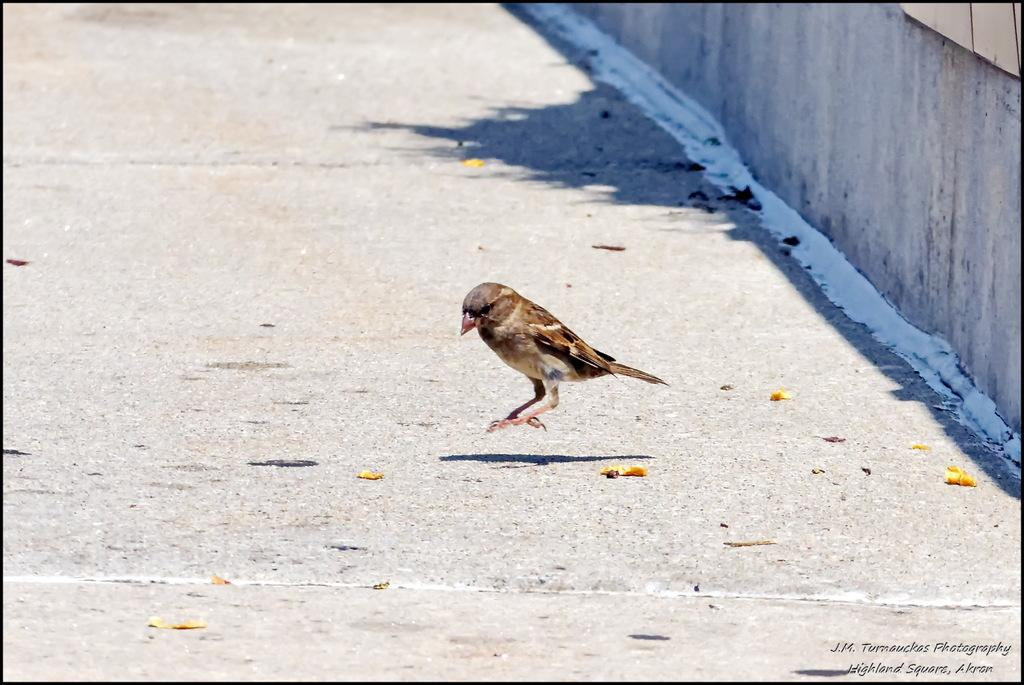What animal can be seen on the road in the image? There is a bird on the road in the image. What type of structure is present in the image? There is a wall in the image. What is placed on the wall? There is an object on the wall. What can be read or seen in the image? There is text visible in the image. What else can be seen on the road besides the bird? There are flower petals on the road. What color is the ink used for the text on the wall? There is no ink present in the image, as the text is not described as being written or printed. What type of arch can be seen in the image? There is no arch present in the image. What is the significance of the quince in the image? There is no quince present in the image. 